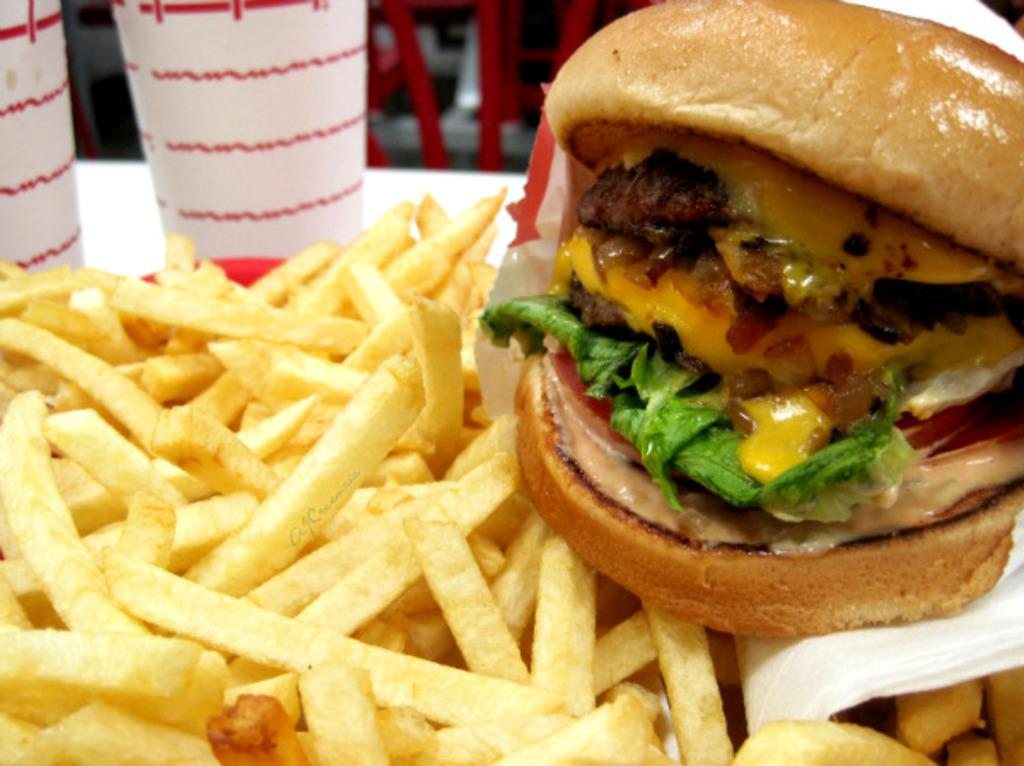What type of food is visible in the image? There is a burger in the image. What can be used for cleaning or wiping in the image? There is tissue paper in the image. What type of side dish is present in the image? There are french fries in the image. What objects are used for drinking in the image? There are glasses in the image. What can be seen in the background of the image? There are objects in the background of the image. What type of apparel is being worn by the burger in the image? There is no apparel present in the image, as the burger is a food item and not a person or living being. 